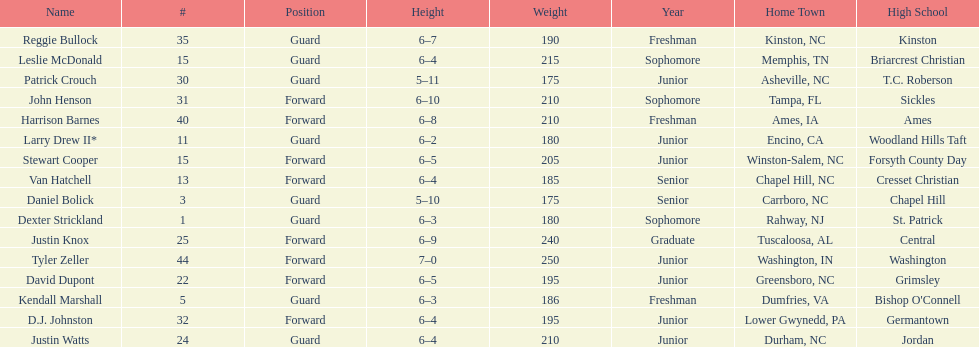Who was taller, justin knox or john henson? John Henson. 